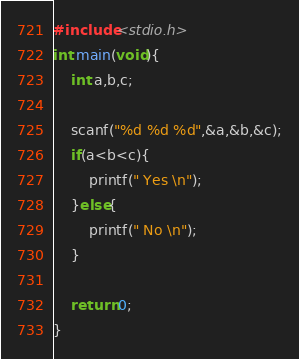Convert code to text. <code><loc_0><loc_0><loc_500><loc_500><_C_>#include<stdio.h>
int main(void){
	int a,b,c;

	scanf("%d %d %d",&a,&b,&c);
	if(a<b<c){
		printf(" Yes \n");
	}else{
		printf(" No \n");
	}

	return 0;
}</code> 